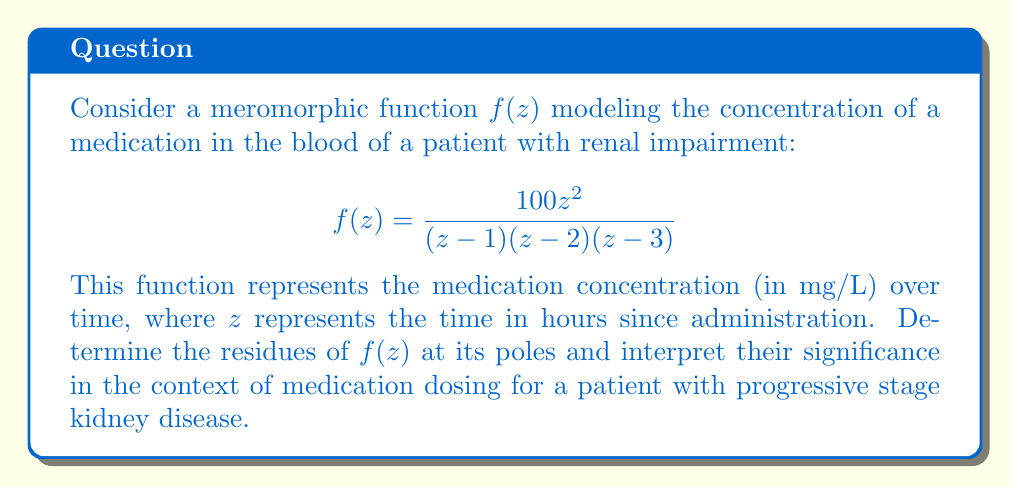Provide a solution to this math problem. To solve this problem, we need to find the residues of $f(z)$ at its poles. The poles are located at $z=1$, $z=2$, and $z=3$.

1. For a simple pole at $z=a$, the residue is given by:
   $$\text{Res}(f,a) = \lim_{z \to a} (z-a)f(z)$$

2. Let's calculate the residue at $z=1$:
   $$\begin{align*}
   \text{Res}(f,1) &= \lim_{z \to 1} (z-1)\frac{100z^2}{(z-1)(z-2)(z-3)} \\
   &= \lim_{z \to 1} \frac{100z^2}{(z-2)(z-3)} \\
   &= \frac{100(1)^2}{(1-2)(1-3)} \\
   &= \frac{100}{2} = 50
   \end{align*}$$

3. For the residue at $z=2$:
   $$\begin{align*}
   \text{Res}(f,2) &= \lim_{z \to 2} (z-2)\frac{100z^2}{(z-1)(z-2)(z-3)} \\
   &= \lim_{z \to 2} \frac{100z^2}{(z-1)(z-3)} \\
   &= \frac{100(2)^2}{(2-1)(2-3)} \\
   &= -400
   \end{align*}$$

4. For the residue at $z=3$:
   $$\begin{align*}
   \text{Res}(f,3) &= \lim_{z \to 3} (z-3)\frac{100z^2}{(z-1)(z-2)(z-3)} \\
   &= \lim_{z \to 3} \frac{100z^2}{(z-1)(z-2)} \\
   &= \frac{100(3)^2}{(3-1)(3-2)} \\
   &= 450
   \end{align*}$$

Interpretation:
The residues represent the rate of change of the medication concentration at specific time points. For a patient with progressive stage kidney disease:

1. At $z=1$ (1 hour after administration), the residue of 50 indicates a moderate rate of concentration change.
2. At $z=2$ (2 hours after administration), the negative residue of -400 suggests a rapid decrease in medication concentration, which could be due to impaired renal function.
3. At $z=3$ (3 hours after administration), the large positive residue of 450 might indicate a rebound effect or accumulation of the medication due to decreased clearance in renal impairment.

These results suggest that the nephrologist should carefully monitor the medication levels and consider adjusting the dosage or frequency for patients with progressive stage kidney disease to avoid potential toxicity or subtherapeutic levels.
Answer: The residues of $f(z)$ at its poles are:
$$\text{Res}(f,1) = 50$$
$$\text{Res}(f,2) = -400$$
$$\text{Res}(f,3) = 450$$ 